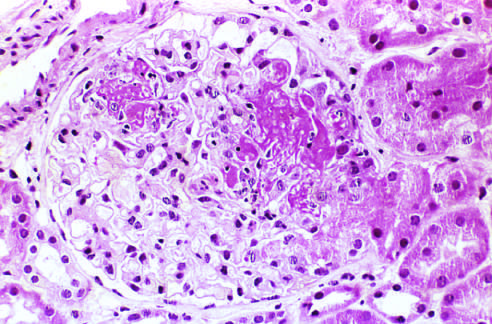how is extracapillary proliferation?
Answer the question using a single word or phrase. Not prominent in this case 